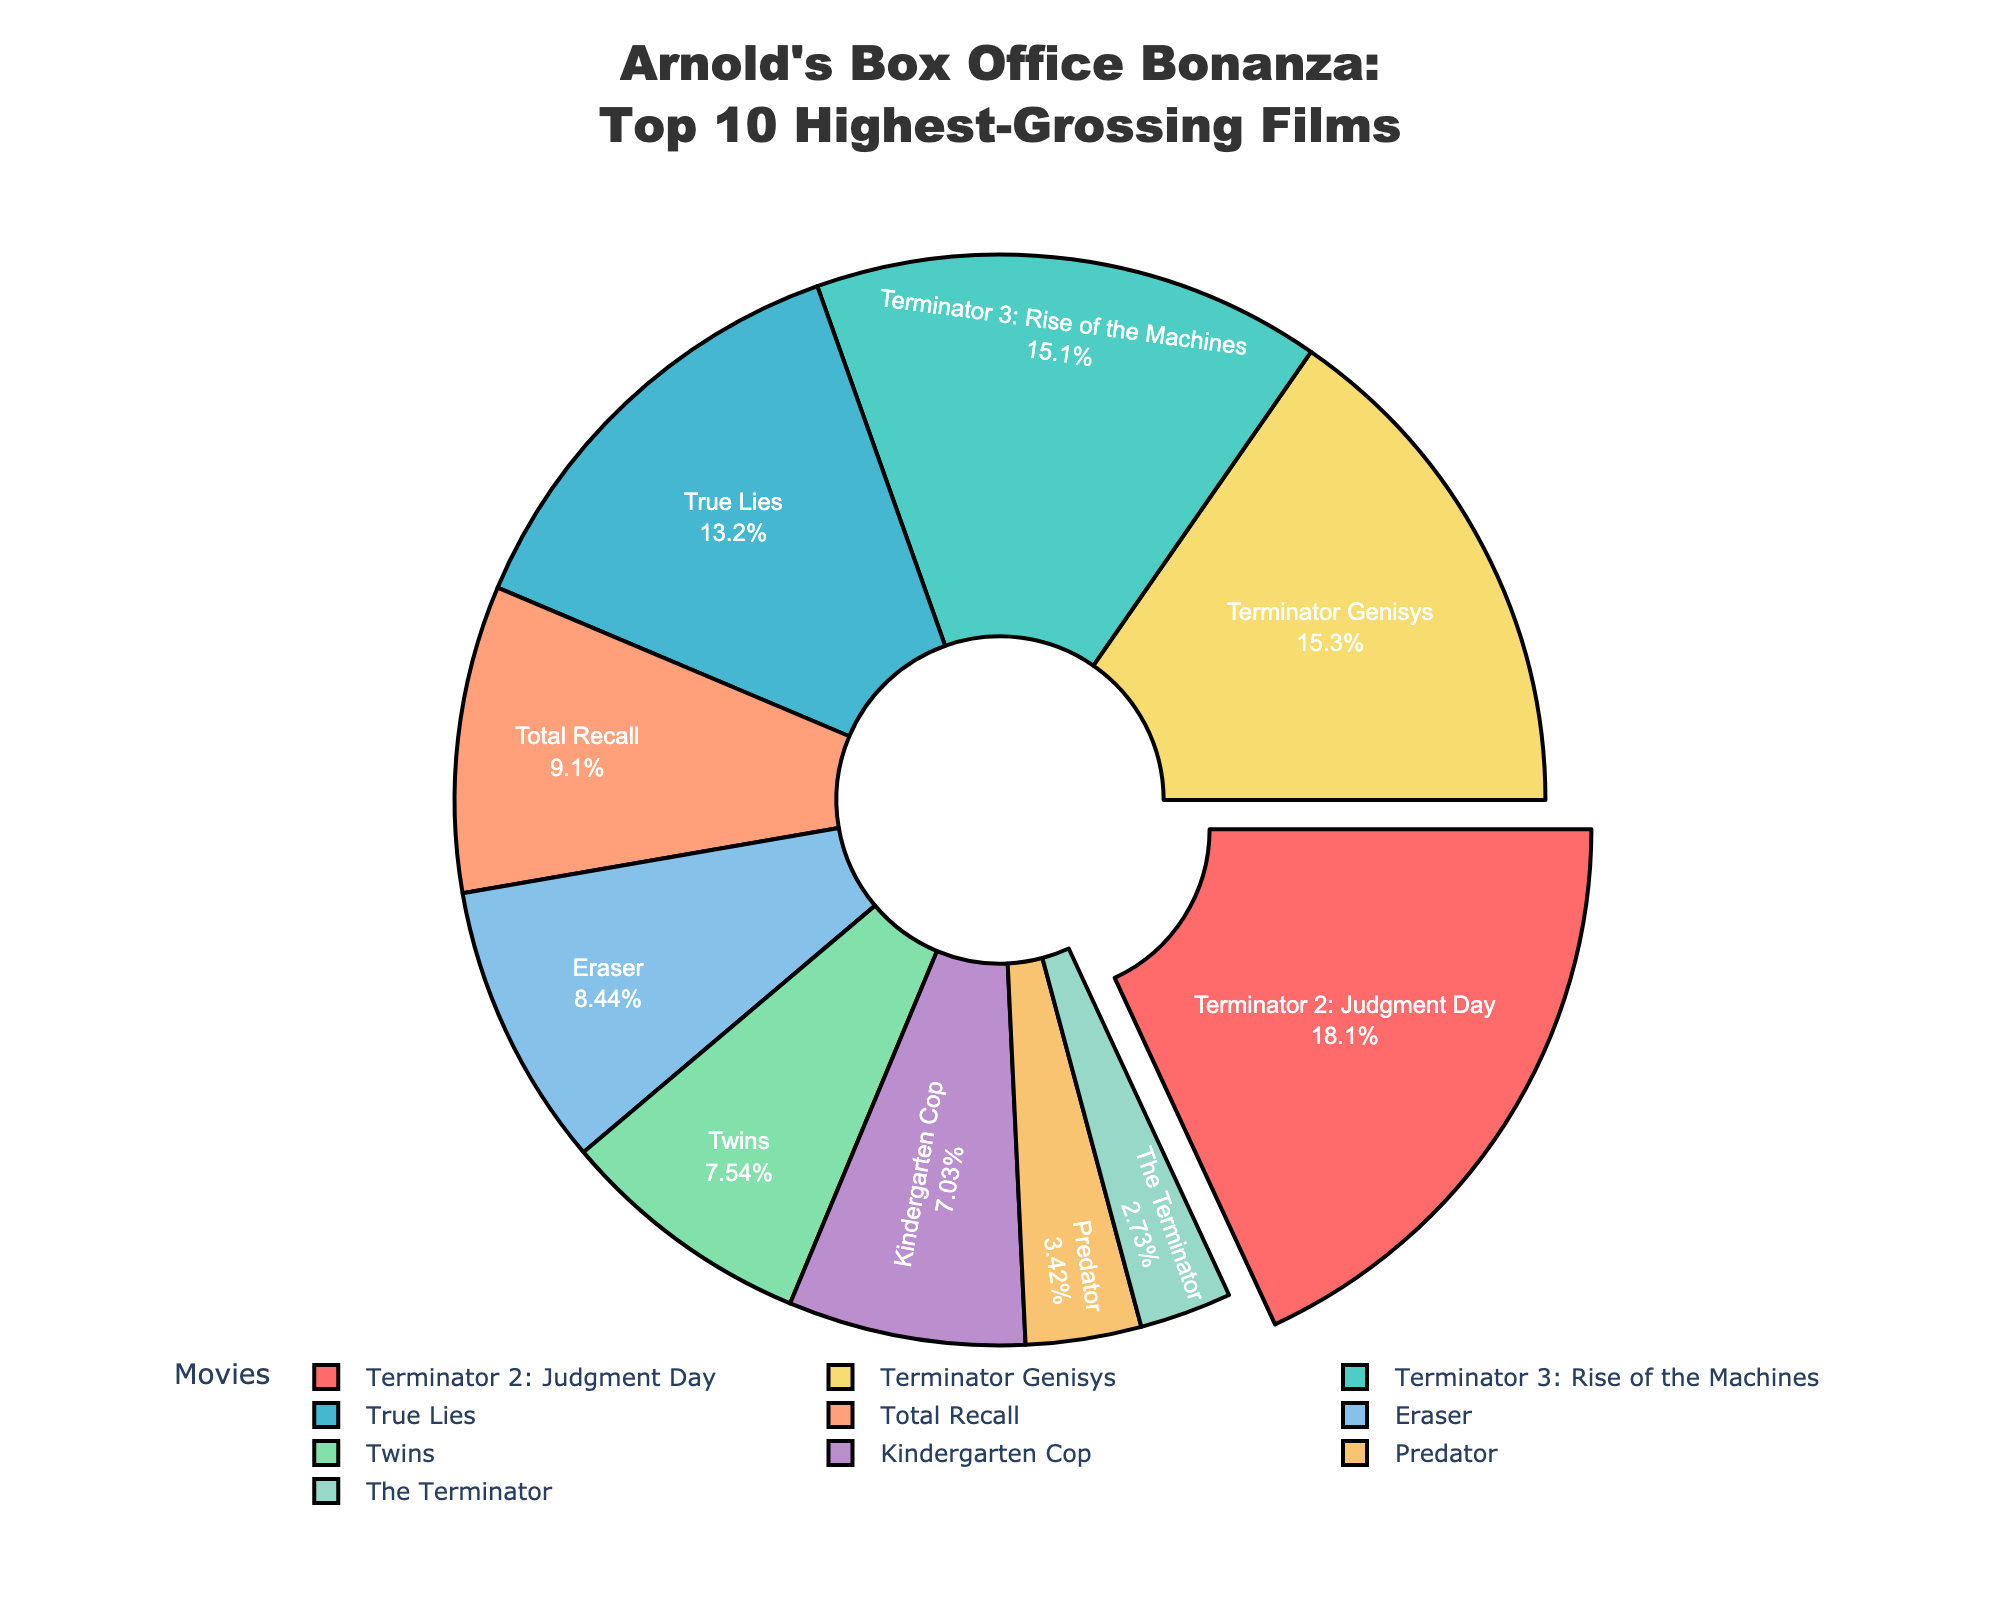Which movie has the highest box office revenue? By looking at the pie chart, identify the percentage labeled "Terminator 2: Judgment Day" and note that it occupies the largest portion of the pie.
Answer: Terminator 2: Judgment Day Which movie made less than 100 million in box office revenue? Look for the smallest segments of the pie chart and hover or check the value to find "The Terminator" which has a revenue of 78.3 million.
Answer: The Terminator How much more did "Terminator Genisys" make than "Eraser"? Find the segments representing "Terminator Genisys" and "Eraser," and subtract their revenues from each other (440.6 - 242.3 = 198.3 million).
Answer: 198.3 million What is the combined box office revenue of the Terminator series (Terminator 2, Terminator 3, The Terminator, Terminator Genisys)? Add the revenues of the Terminator series movies together: 519.8 + 433.4 + 78.3 + 440.6 = 1472.1 million.
Answer: 1472.1 million Is "True Lies" or "Total Recall" more successful in terms of box office revenue? Compare the revenue percentages or direct values on the pie chart and note that "True Lies" has a higher value than "Total Recall" (378.9 > 261.3).
Answer: True Lies How many movies made over 200 million in box office revenue? Count the segments of the pie chart with revenues over 200 million: Terminator 2, Terminator 3, True Lies, Terminator Genisys, and three more (6 in total).
Answer: 7 movies What percentage of the total box office revenue is attributed to "Kindergarten Cop"? Find the segment for "Kindergarten Cop" and look at its percentage label.
Answer: Approximately 7.5% Among "Predator" and "Twins," which movie has a higher box office revenue? Locate the segments for "Predator" and "Twins" and compare their values; "Twins" has a higher value (216.6 > 98.3).
Answer: Twins What's the average box office revenue of all the movies listed? Sum all the revenues and divide by the number of movies: (519.8 + 433.4 + 378.9 + 261.3 + 78.3 + 440.6 + 202.0 + 216.6 + 98.3 + 242.3) / 10 = 2871 / 10 = 287.1 million.
Answer: 287.1 million Which movie's revenue forms the smallest segment on the pie chart? Identify the segment with the smallest portion, which is labeled "The Terminator".
Answer: The Terminator 